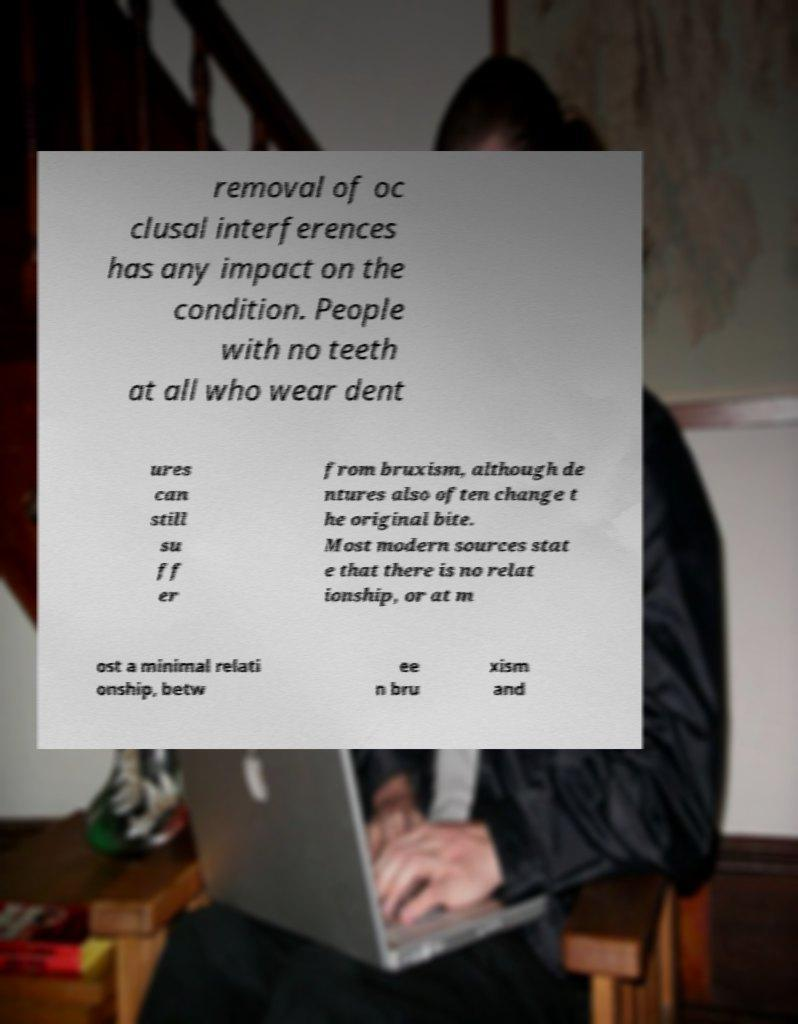I need the written content from this picture converted into text. Can you do that? removal of oc clusal interferences has any impact on the condition. People with no teeth at all who wear dent ures can still su ff er from bruxism, although de ntures also often change t he original bite. Most modern sources stat e that there is no relat ionship, or at m ost a minimal relati onship, betw ee n bru xism and 